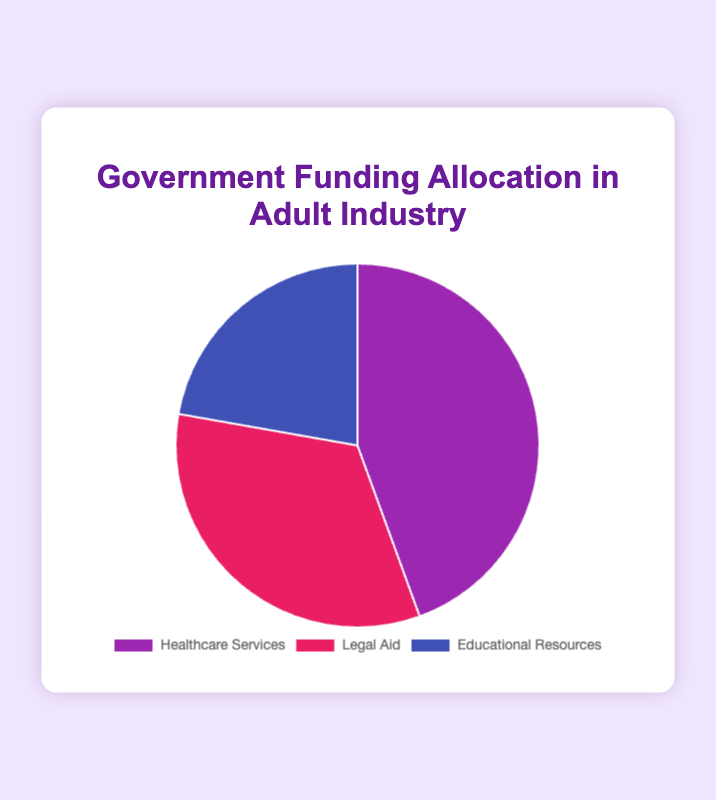What percentage of the total funding is allocated to Healthcare Services? To find the percentage, divide the amount allocated to Healthcare Services by the total funding amount, then multiply by 100. The total funding is 20 + 15 + 10 = 45 million. The percentage is (20/45) * 100 ≈ 44.44%.
Answer: 44.44% How much more funding is allocated to Healthcare Services than to Educational Resources? Subtract the funding amount of Educational Resources from Healthcare Services: 20 million - 10 million = 10 million.
Answer: 10 million Which category receives the least amount of funding? The category with the smallest amount in the chart is Educational Resources, which receives 10 million USD.
Answer: Educational Resources What is the combined funding for Legal Aid and Educational Resources? Add the funding amounts of Legal Aid and Educational Resources: 15 million + 10 million = 25 million.
Answer: 25 million What is the average amount of funding allocated per category? The total funding is 45 million and there are 3 categories. Divide the total by the number of categories: 45 million / 3 = 15 million.
Answer: 15 million Is the funding for Healthcare Services greater than the combined funding for Legal Aid and Educational Resources? Combine the funding amounts for Legal Aid and Educational Resources: 15 million + 10 million = 25 million. Compare this to Healthcare Services, which is 20 million. 20 million is less than 25 million.
Answer: No If the funding for Educational Resources doubled, would it exceed the current funding for Healthcare Services? Double the funding for Educational Resources: 10 million * 2 = 20 million. Compare this to Healthcare Services, which is also 20 million. They would be equal.
Answer: No What is the ratio of funding for Healthcare Services to the total funding? The ratio is calculated by dividing the funding for Healthcare Services by the total funding: 20 million / 45 million ≈ 0.444.
Answer: 0.444 What proportion of the total funding is allocated to Legal Aid? Calculate the proportion by dividing the funding for Legal Aid by the total funding amount and then multiplying by 100: (15/45) * 100 ≈ 33.33%.
Answer: 33.33% 